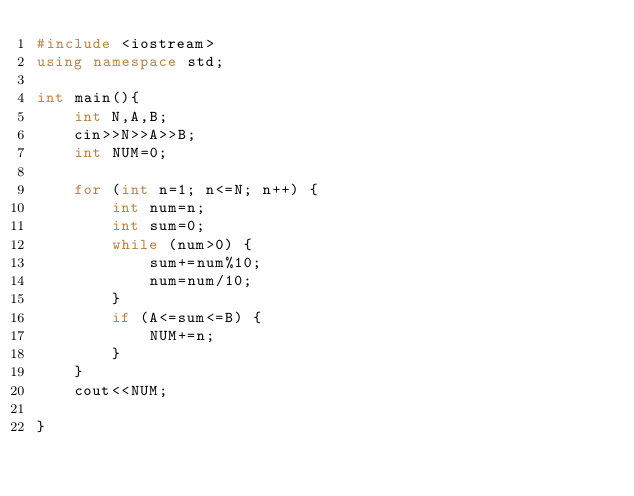<code> <loc_0><loc_0><loc_500><loc_500><_C++_>#include <iostream>
using namespace std;

int main(){
    int N,A,B;
    cin>>N>>A>>B;
    int NUM=0;
    
    for (int n=1; n<=N; n++) {
        int num=n;
        int sum=0;
        while (num>0) {
            sum+=num%10;
            num=num/10;
        }
        if (A<=sum<=B) {
            NUM+=n;
        }
    }
    cout<<NUM;
    
}
</code> 